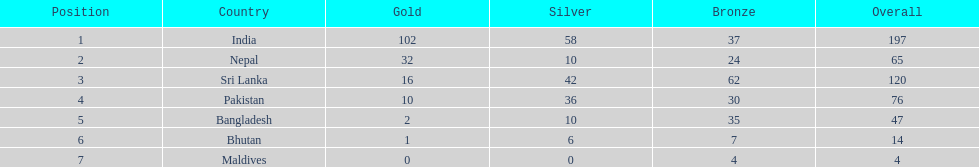Which nation has earned the least amount of gold medals? Maldives. 